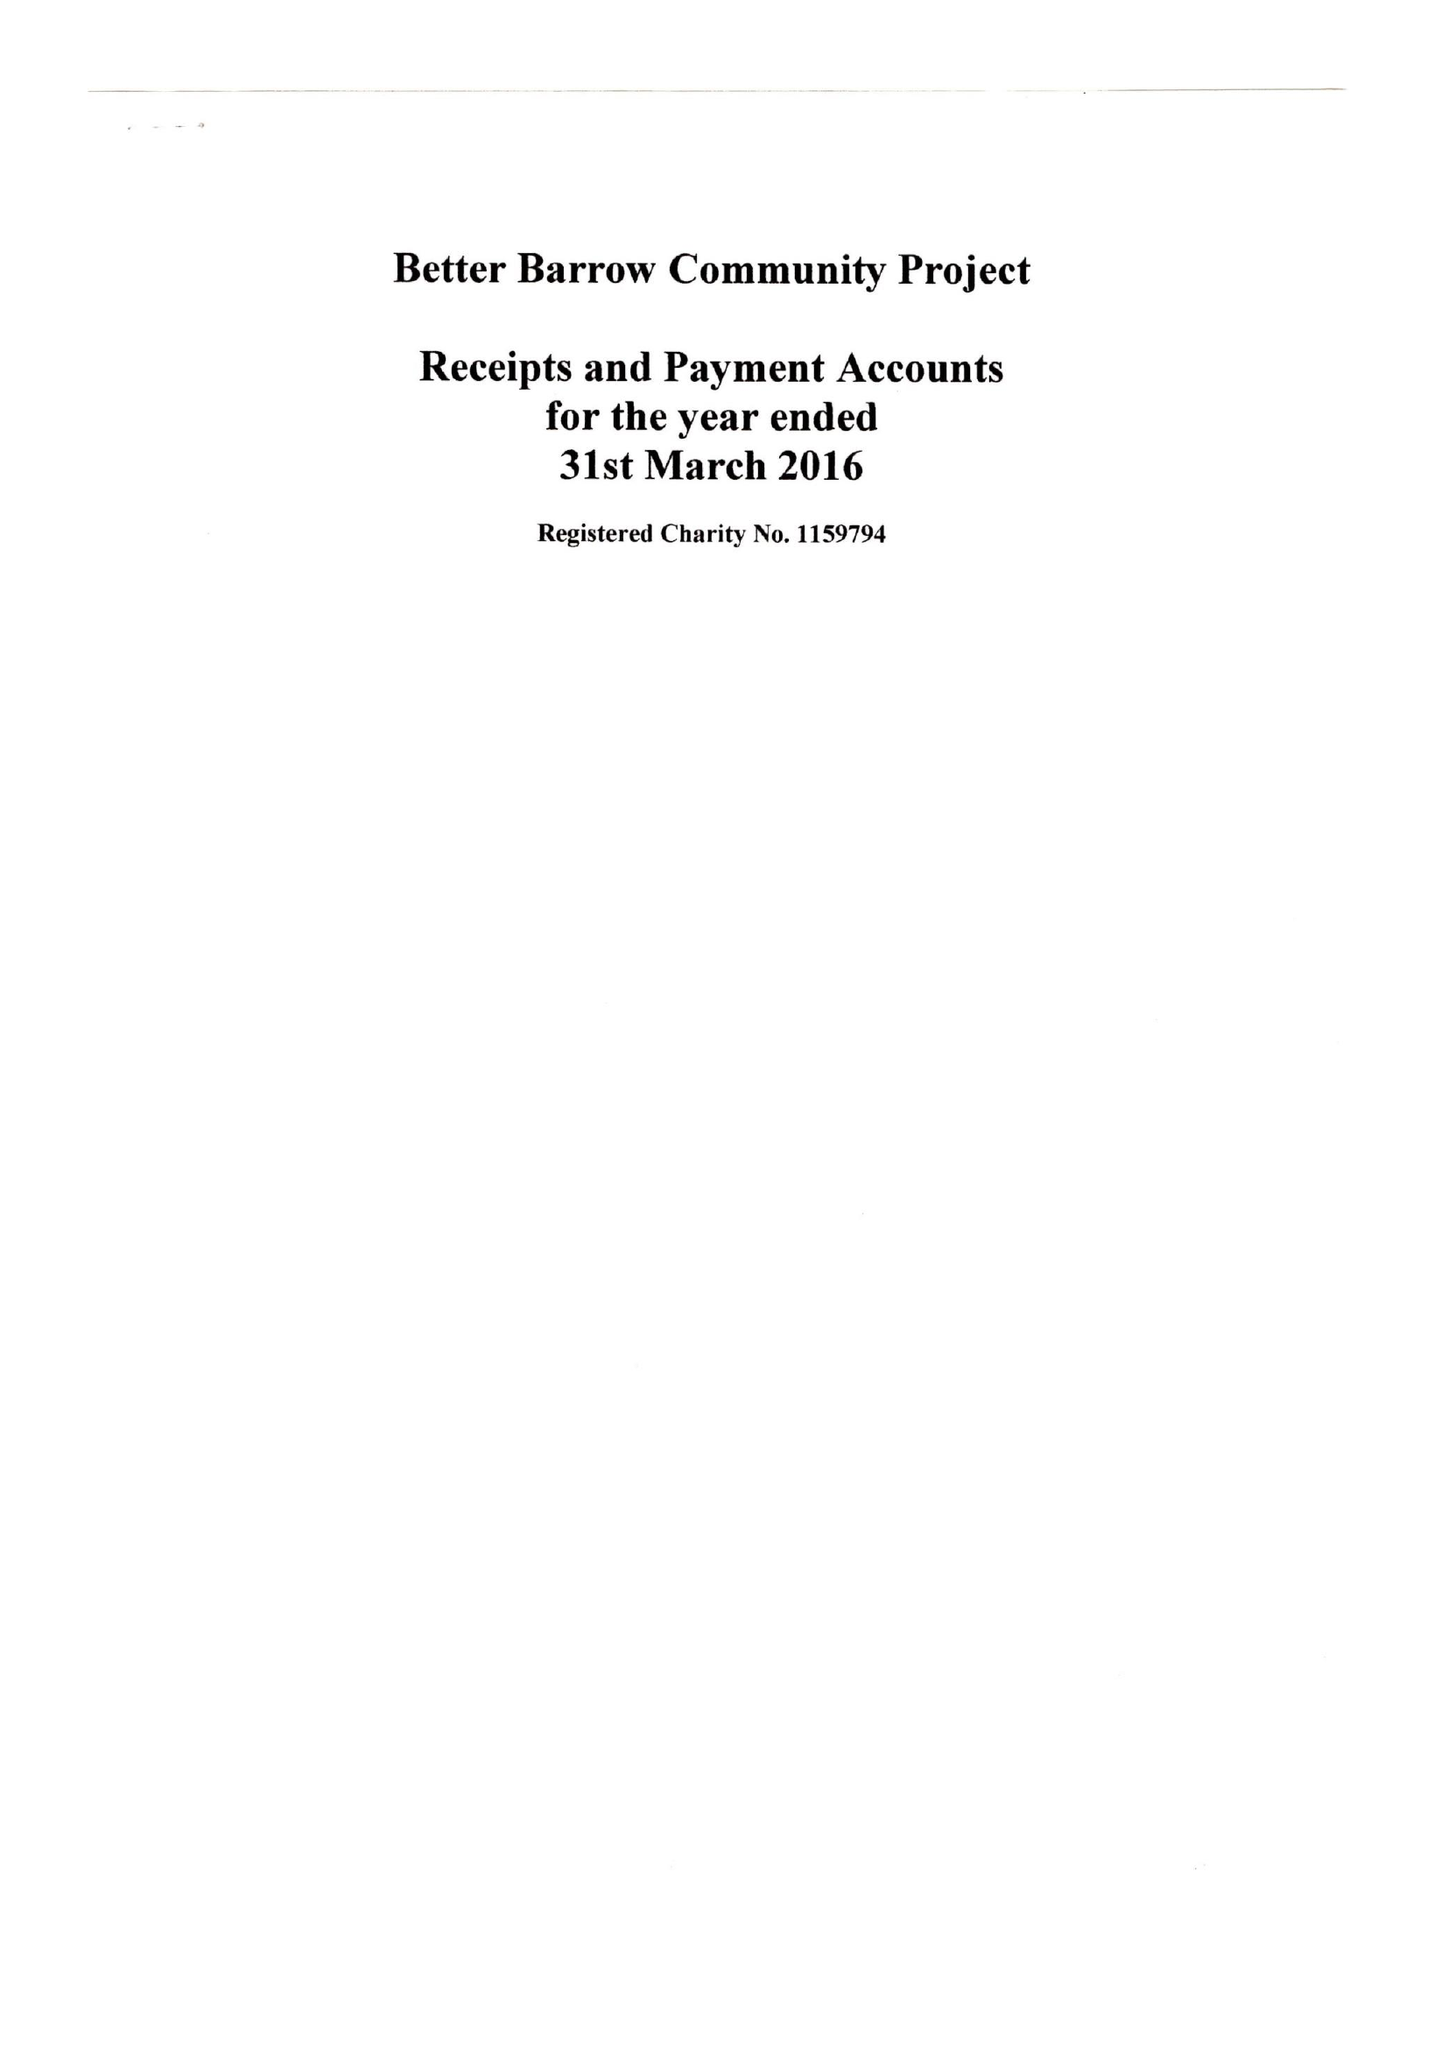What is the value for the address__post_town?
Answer the question using a single word or phrase. BARROW-UPON-HUMBER 